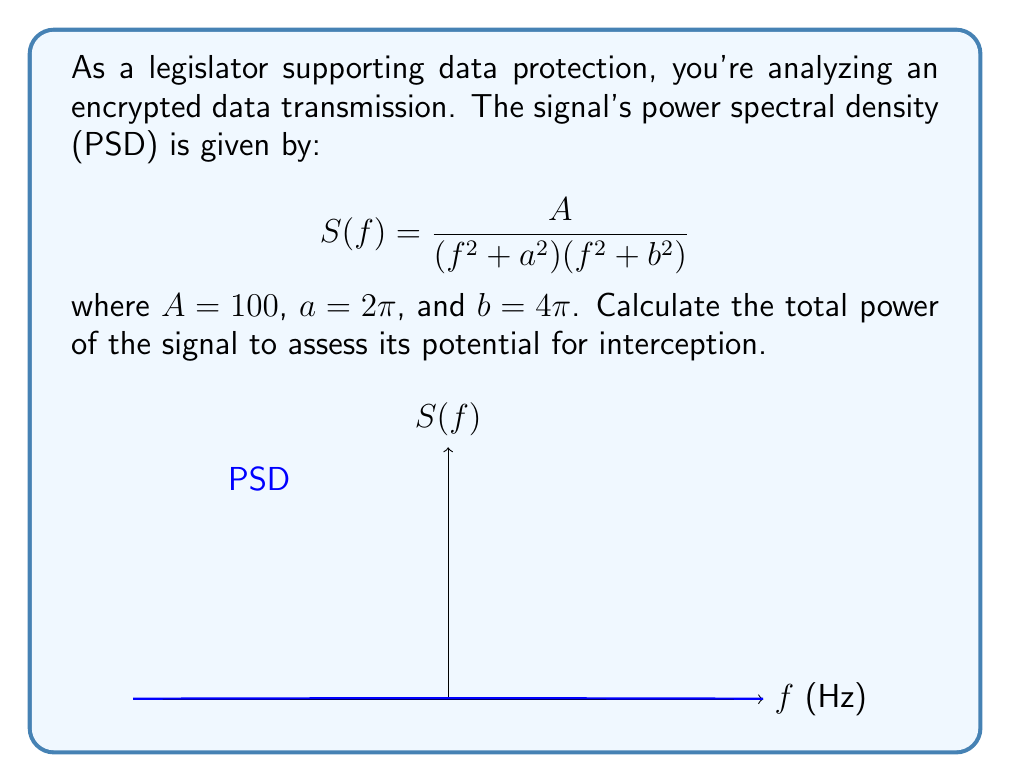Show me your answer to this math problem. To find the total power of the signal, we need to integrate the PSD over all frequencies:

1) The total power $P$ is given by:
   $$P = \int_{-\infty}^{\infty} S(f) df$$

2) Substituting our PSD function:
   $$P = \int_{-\infty}^{\infty} \frac{A}{(f^2 + a^2)(f^2 + b^2)} df$$

3) This integral can be solved using partial fraction decomposition and the residue theorem. The result is:
   $$P = \frac{\pi A}{a b (a + b)}$$

4) Substituting the given values:
   $$P = \frac{\pi \cdot 100}{(2\pi)(4\pi)(2\pi + 4\pi)}$$

5) Simplifying:
   $$P = \frac{100}{24\pi^2}$$

6) Evaluating:
   $$P \approx 0.4214 \text{ W}$$

This power level indicates the strength of the signal and its potential for interception, which is crucial information for data protection legislation.
Answer: $\frac{100}{24\pi^2}$ W or approximately 0.4214 W 